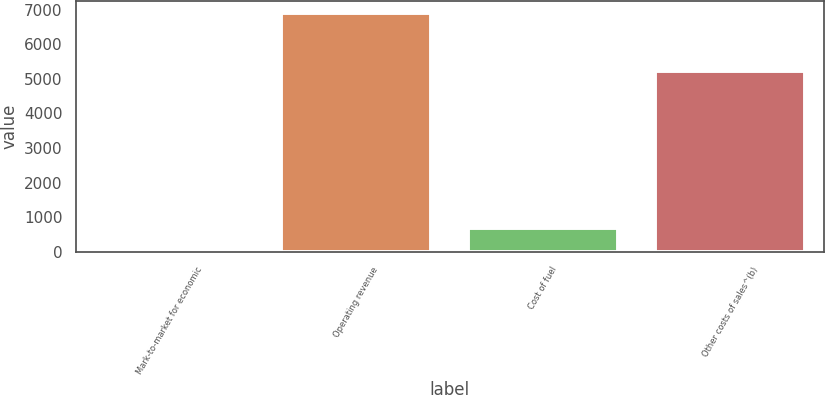Convert chart to OTSL. <chart><loc_0><loc_0><loc_500><loc_500><bar_chart><fcel>Mark-to-market for economic<fcel>Operating revenue<fcel>Cost of fuel<fcel>Other costs of sales^(b)<nl><fcel>4<fcel>6913<fcel>694.9<fcel>5236<nl></chart> 